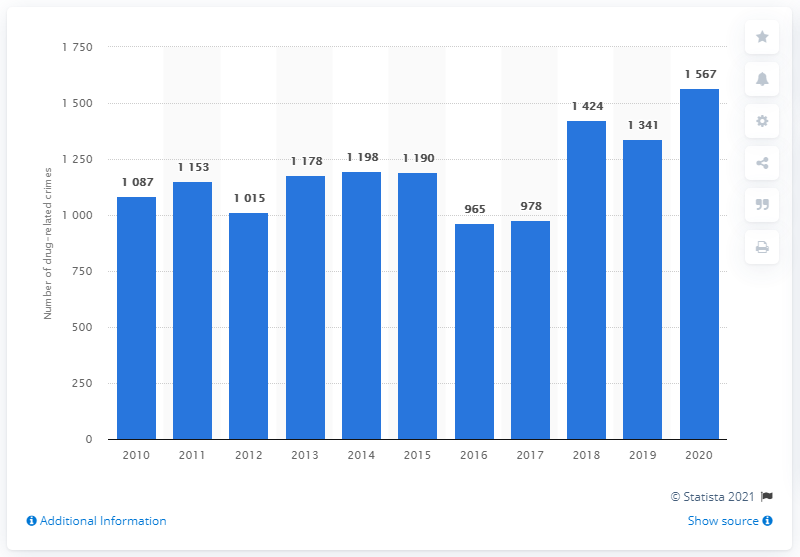Indicate a few pertinent items in this graphic. In 2016, a total of 965 drug-related crimes were reported in Denmark. 